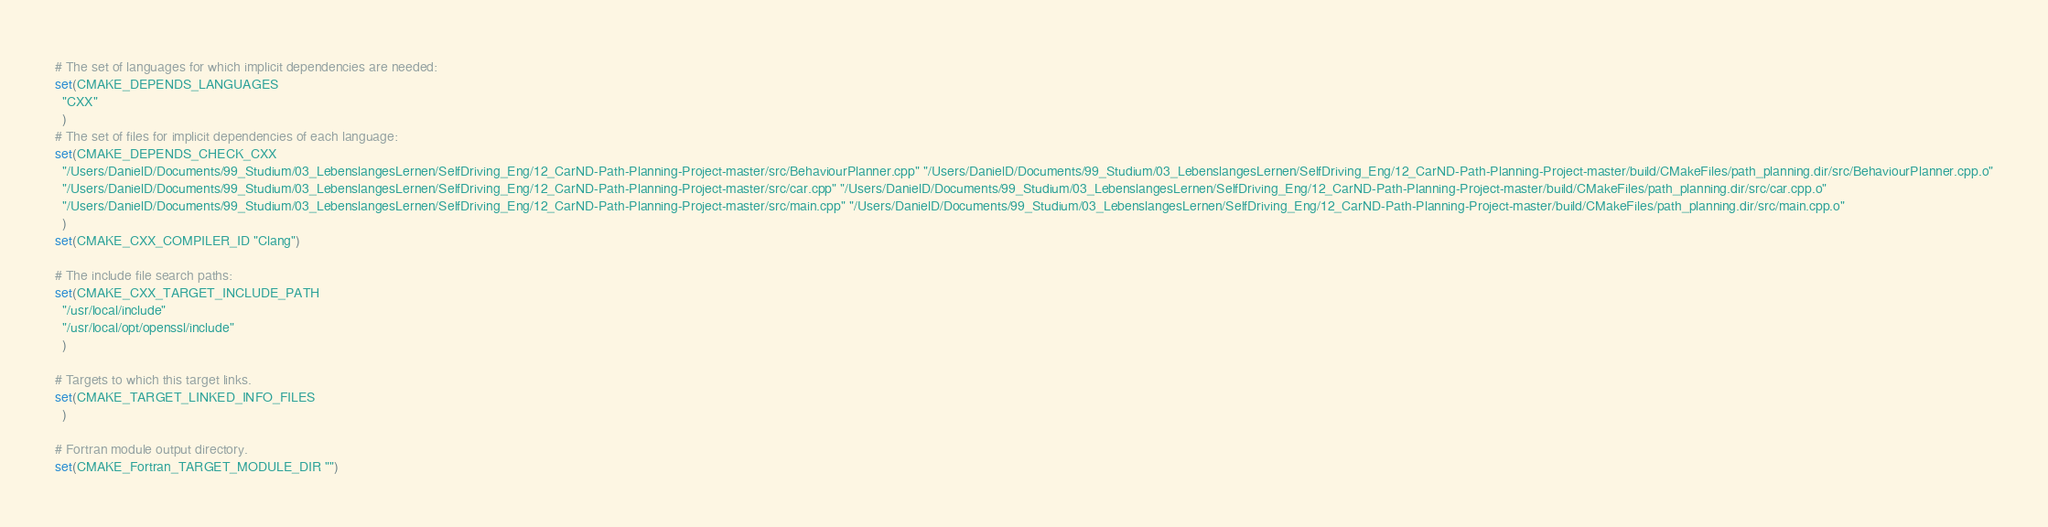Convert code to text. <code><loc_0><loc_0><loc_500><loc_500><_CMake_># The set of languages for which implicit dependencies are needed:
set(CMAKE_DEPENDS_LANGUAGES
  "CXX"
  )
# The set of files for implicit dependencies of each language:
set(CMAKE_DEPENDS_CHECK_CXX
  "/Users/DanielD/Documents/99_Studium/03_LebenslangesLernen/SelfDriving_Eng/12_CarND-Path-Planning-Project-master/src/BehaviourPlanner.cpp" "/Users/DanielD/Documents/99_Studium/03_LebenslangesLernen/SelfDriving_Eng/12_CarND-Path-Planning-Project-master/build/CMakeFiles/path_planning.dir/src/BehaviourPlanner.cpp.o"
  "/Users/DanielD/Documents/99_Studium/03_LebenslangesLernen/SelfDriving_Eng/12_CarND-Path-Planning-Project-master/src/car.cpp" "/Users/DanielD/Documents/99_Studium/03_LebenslangesLernen/SelfDriving_Eng/12_CarND-Path-Planning-Project-master/build/CMakeFiles/path_planning.dir/src/car.cpp.o"
  "/Users/DanielD/Documents/99_Studium/03_LebenslangesLernen/SelfDriving_Eng/12_CarND-Path-Planning-Project-master/src/main.cpp" "/Users/DanielD/Documents/99_Studium/03_LebenslangesLernen/SelfDriving_Eng/12_CarND-Path-Planning-Project-master/build/CMakeFiles/path_planning.dir/src/main.cpp.o"
  )
set(CMAKE_CXX_COMPILER_ID "Clang")

# The include file search paths:
set(CMAKE_CXX_TARGET_INCLUDE_PATH
  "/usr/local/include"
  "/usr/local/opt/openssl/include"
  )

# Targets to which this target links.
set(CMAKE_TARGET_LINKED_INFO_FILES
  )

# Fortran module output directory.
set(CMAKE_Fortran_TARGET_MODULE_DIR "")
</code> 